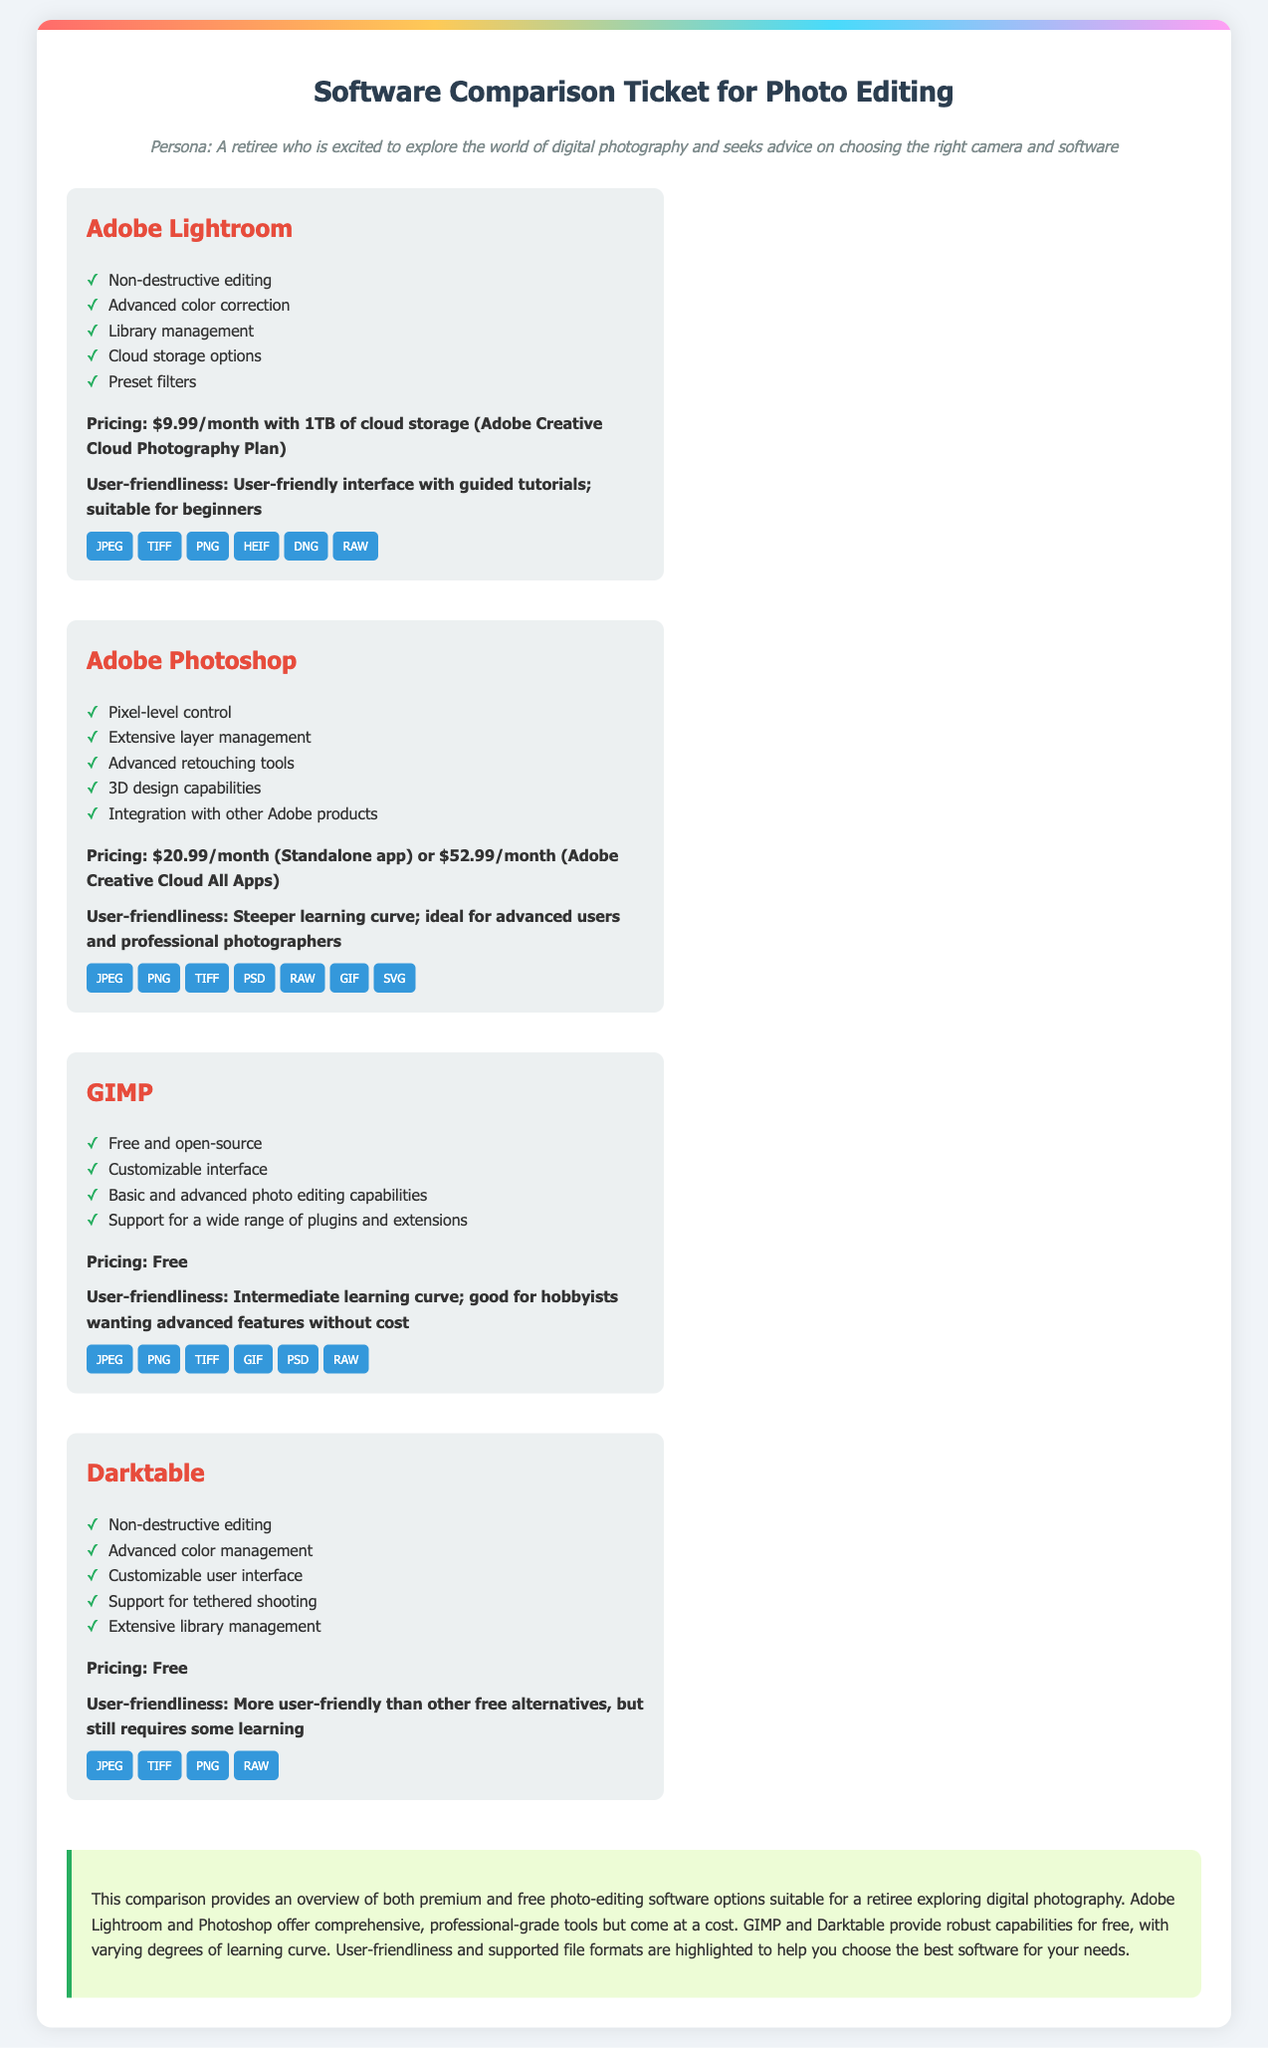What is the pricing for Adobe Lightroom? The pricing for Adobe Lightroom is $9.99/month with 1TB of cloud storage as part of the Adobe Creative Cloud Photography Plan.
Answer: $9.99/month Which software is free and open-source? The software that is free and open-source is GIMP.
Answer: GIMP What key feature is unique to Adobe Photoshop? A unique key feature of Adobe Photoshop is 3D design capabilities.
Answer: 3D design capabilities How user-friendly is Darktable described? Darktable is described as more user-friendly than other free alternatives, but still requires some learning.
Answer: More user-friendly than other free alternatives What file formats do all listed software support? All listed software supports the JPEG file format.
Answer: JPEG What is the pricing for Adobe Photoshop standalone? The pricing for Adobe Photoshop as a standalone app is $20.99/month.
Answer: $20.99/month How does the user-friendliness of GIMP compare? The user-friendliness of GIMP has an intermediate learning curve; it is good for hobbyists wanting advanced features without cost.
Answer: Intermediate learning curve What is the main advantage of non-destructive editing? The main advantage of non-destructive editing is that it allows for changes without permanently altering the original image.
Answer: Changes without permanently altering the original image 